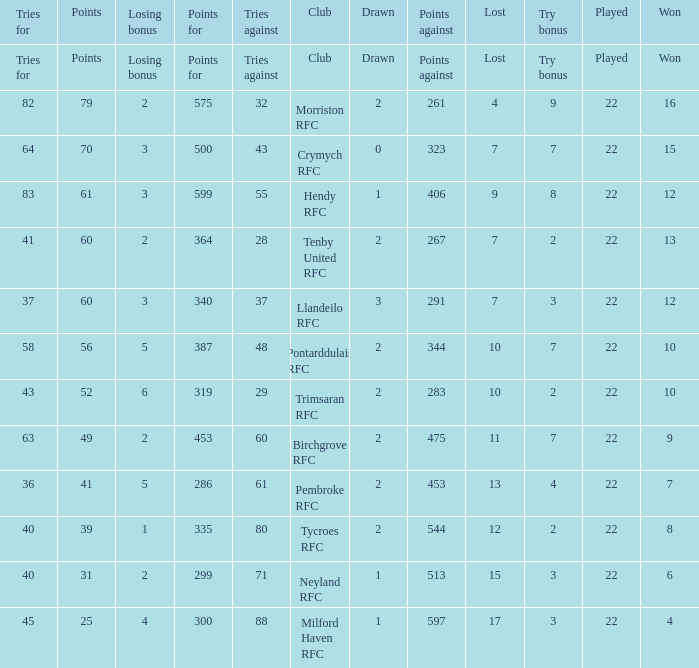What's the points with tries for being 64 70.0. Can you parse all the data within this table? {'header': ['Tries for', 'Points', 'Losing bonus', 'Points for', 'Tries against', 'Club', 'Drawn', 'Points against', 'Lost', 'Try bonus', 'Played', 'Won'], 'rows': [['Tries for', 'Points', 'Losing bonus', 'Points for', 'Tries against', 'Club', 'Drawn', 'Points against', 'Lost', 'Try bonus', 'Played', 'Won'], ['82', '79', '2', '575', '32', 'Morriston RFC', '2', '261', '4', '9', '22', '16'], ['64', '70', '3', '500', '43', 'Crymych RFC', '0', '323', '7', '7', '22', '15'], ['83', '61', '3', '599', '55', 'Hendy RFC', '1', '406', '9', '8', '22', '12'], ['41', '60', '2', '364', '28', 'Tenby United RFC', '2', '267', '7', '2', '22', '13'], ['37', '60', '3', '340', '37', 'Llandeilo RFC', '3', '291', '7', '3', '22', '12'], ['58', '56', '5', '387', '48', 'Pontarddulais RFC', '2', '344', '10', '7', '22', '10'], ['43', '52', '6', '319', '29', 'Trimsaran RFC', '2', '283', '10', '2', '22', '10'], ['63', '49', '2', '453', '60', 'Birchgrove RFC', '2', '475', '11', '7', '22', '9'], ['36', '41', '5', '286', '61', 'Pembroke RFC', '2', '453', '13', '4', '22', '7'], ['40', '39', '1', '335', '80', 'Tycroes RFC', '2', '544', '12', '2', '22', '8'], ['40', '31', '2', '299', '71', 'Neyland RFC', '1', '513', '15', '3', '22', '6'], ['45', '25', '4', '300', '88', 'Milford Haven RFC', '1', '597', '17', '3', '22', '4']]} 